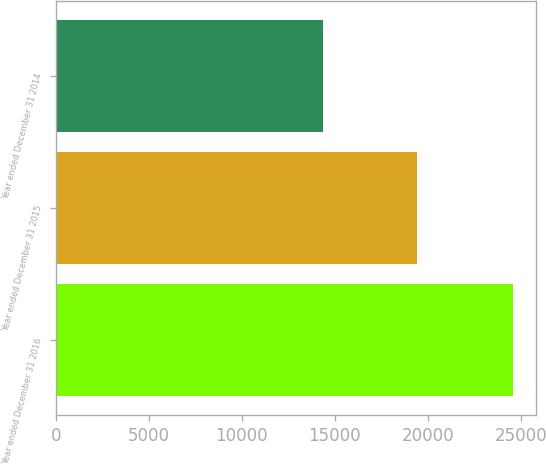Convert chart to OTSL. <chart><loc_0><loc_0><loc_500><loc_500><bar_chart><fcel>Year ended December 31 2016<fcel>Year ended December 31 2015<fcel>Year ended December 31 2014<nl><fcel>24583<fcel>19426<fcel>14360<nl></chart> 